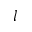Convert formula to latex. <formula><loc_0><loc_0><loc_500><loc_500>l</formula> 